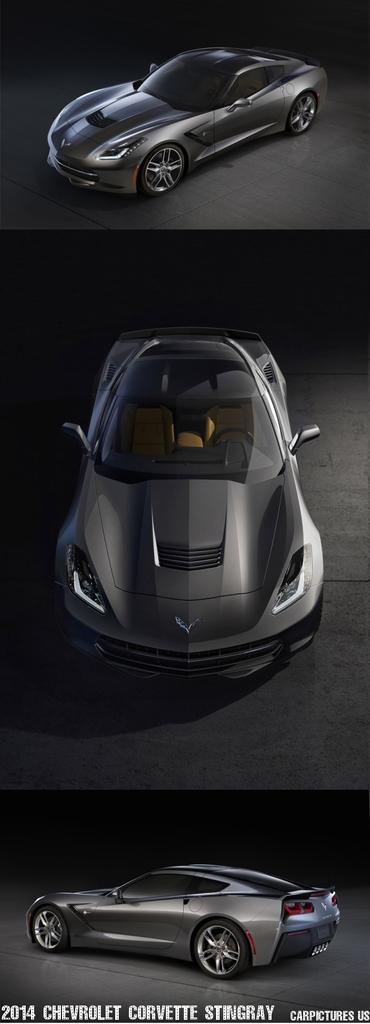Please provide a concise description of this image. This is a collage image. In this picture we can see the cars on the floor. At the bottom of the image we can see the text. 